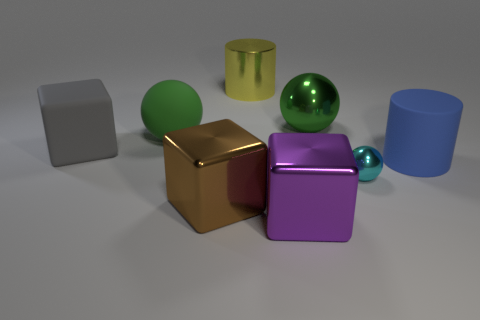How big is the cylinder on the left side of the big matte object in front of the large cube behind the blue cylinder? If we are considering the perspective of the image where the blue cylinder is in the right foreground, the cylinder on the left side of the big matte (which appears to be a purple matte cube) is relatively small compared to the larger objects in the image. However, without a specific reference for size, we can only say that it is smaller than the purple matte cube and the large cube behind the blue cylinder. It is important to note that the actual size cannot be determined definitively without more context or a reference measure. 